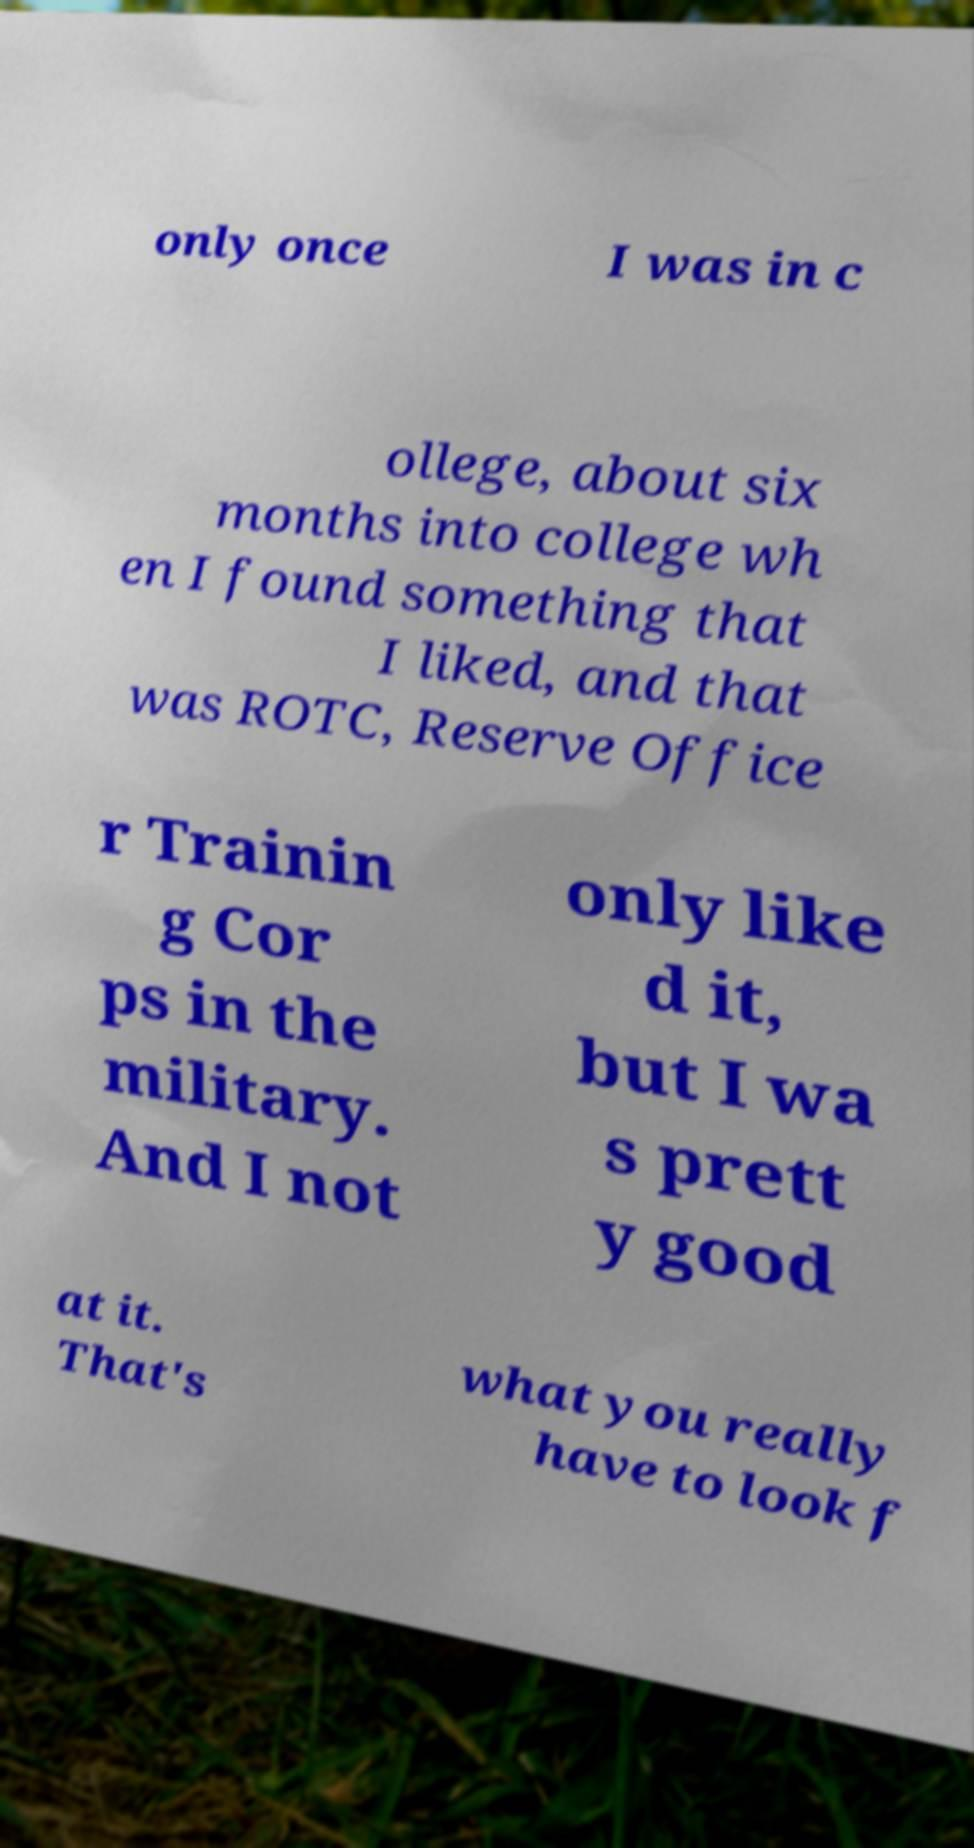Please read and relay the text visible in this image. What does it say? only once I was in c ollege, about six months into college wh en I found something that I liked, and that was ROTC, Reserve Office r Trainin g Cor ps in the military. And I not only like d it, but I wa s prett y good at it. That's what you really have to look f 